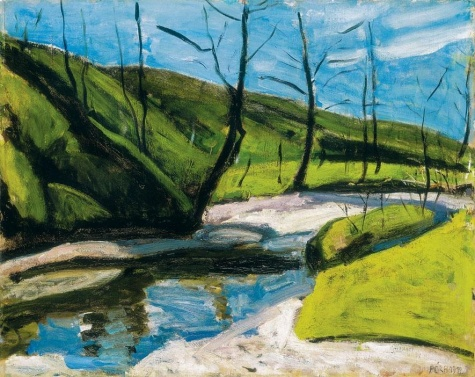What do you think is going on in this snapshot? The image portrays an early spring scene in an impressionist style, likely executed using oil paint on canvas. The dominant hues of green and blue evoke a sense of renewal and calm. A river meanders gently through a valley, flanked by the youthful greenery of new grass and budding trees. The bare branches suggest it's early in the season, possibly late winter or early spring, highlighting nature's cycle of rebirth. Several elements, like the reflection in the water and the texture of the grass, are rendered with brisk brushstrokes typical of the impressionist movement. Signed 'Pissarro', this painting might draw inspiration from landscapes typical to this artist's oeuvre, suggesting a personal or historical narrative embedded in the depiction of this tranquil landscape. 